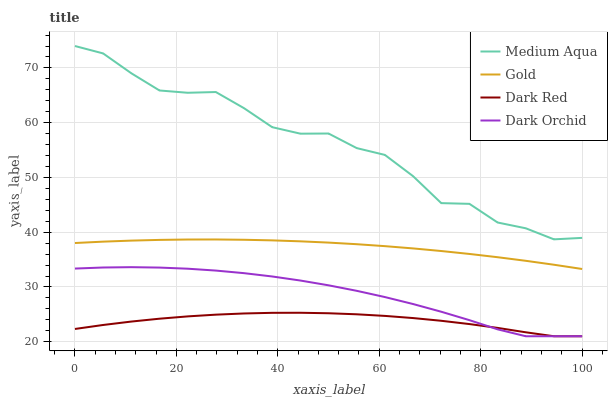Does Dark Red have the minimum area under the curve?
Answer yes or no. Yes. Does Medium Aqua have the maximum area under the curve?
Answer yes or no. Yes. Does Dark Orchid have the minimum area under the curve?
Answer yes or no. No. Does Dark Orchid have the maximum area under the curve?
Answer yes or no. No. Is Gold the smoothest?
Answer yes or no. Yes. Is Medium Aqua the roughest?
Answer yes or no. Yes. Is Dark Orchid the smoothest?
Answer yes or no. No. Is Dark Orchid the roughest?
Answer yes or no. No. Does Dark Red have the lowest value?
Answer yes or no. Yes. Does Medium Aqua have the lowest value?
Answer yes or no. No. Does Medium Aqua have the highest value?
Answer yes or no. Yes. Does Dark Orchid have the highest value?
Answer yes or no. No. Is Gold less than Medium Aqua?
Answer yes or no. Yes. Is Medium Aqua greater than Dark Red?
Answer yes or no. Yes. Does Dark Orchid intersect Dark Red?
Answer yes or no. Yes. Is Dark Orchid less than Dark Red?
Answer yes or no. No. Is Dark Orchid greater than Dark Red?
Answer yes or no. No. Does Gold intersect Medium Aqua?
Answer yes or no. No. 